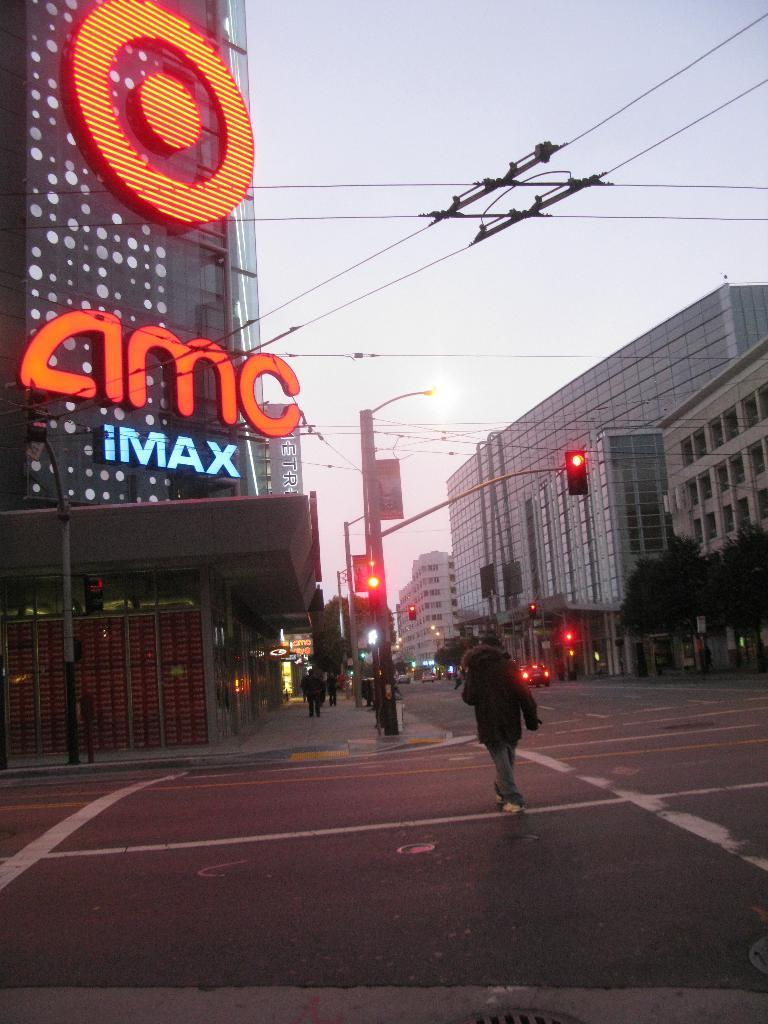<image>
Render a clear and concise summary of the photo. an amc theater that is located outside at night 